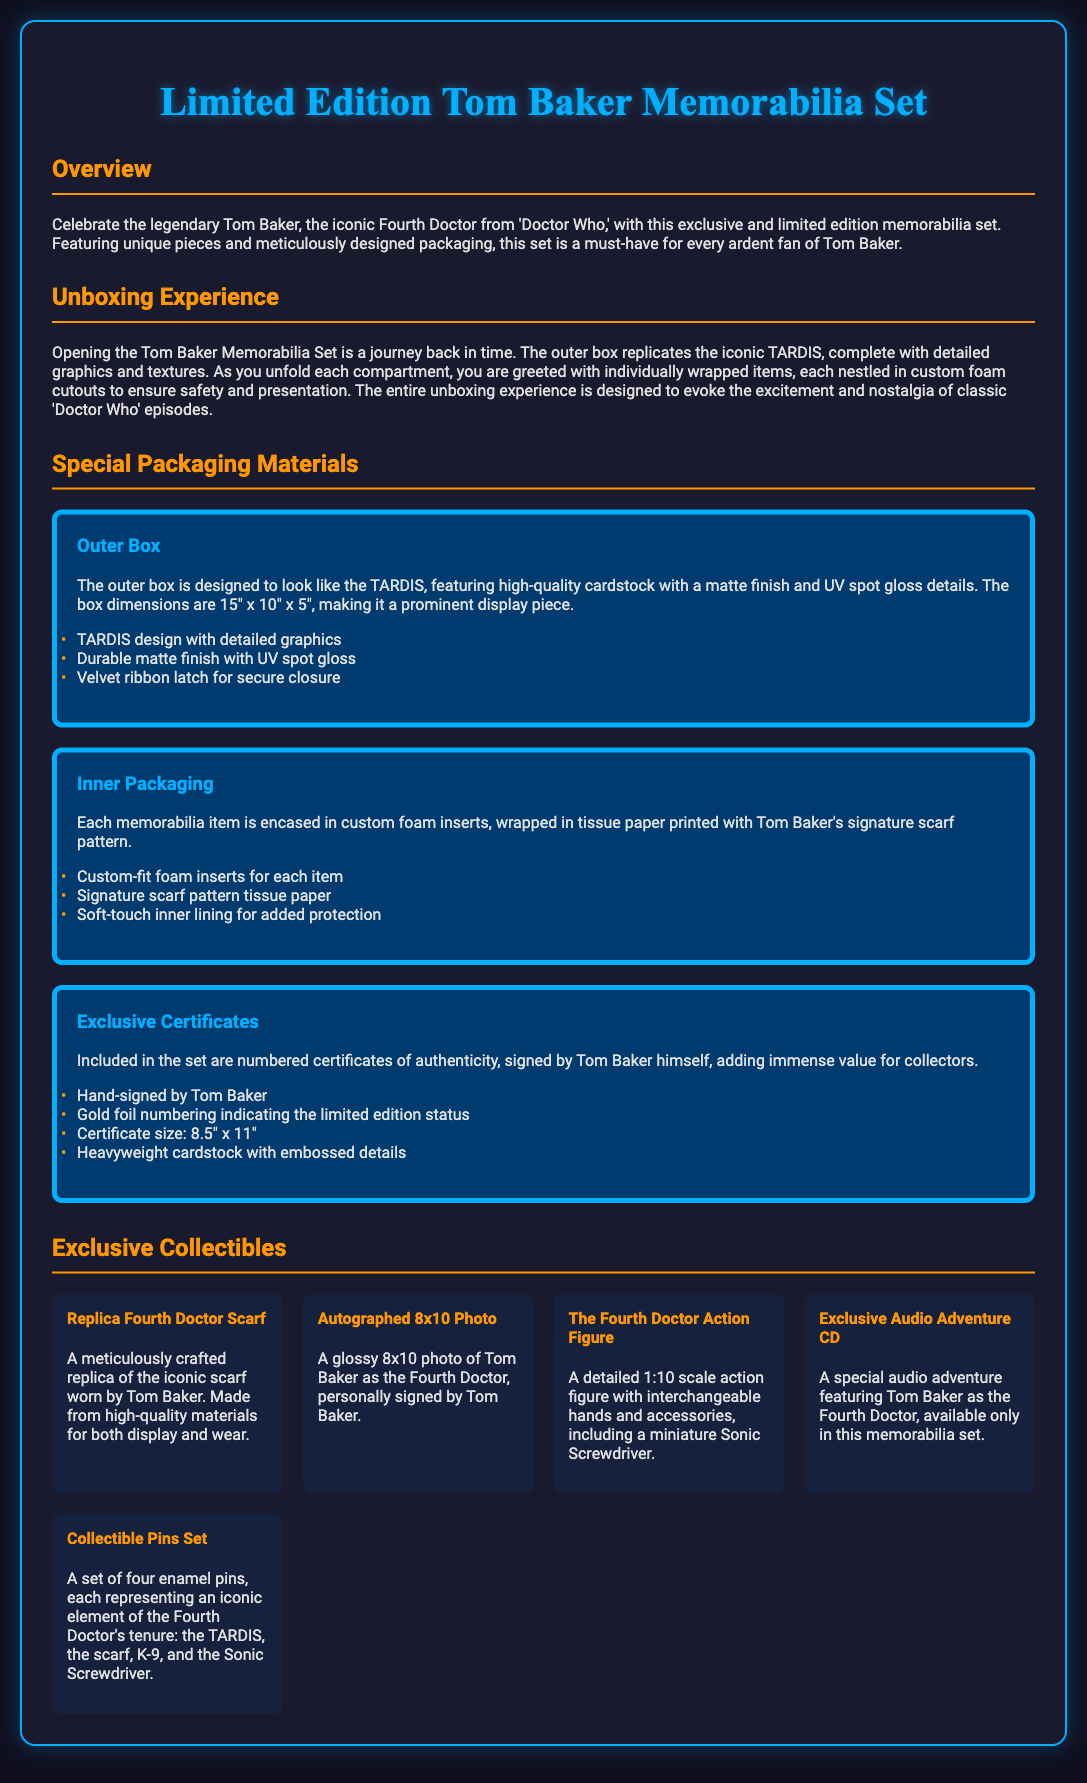What is the main theme of the memorabilia set? The main theme of the set is to celebrate Tom Baker, the iconic Fourth Doctor from 'Doctor Who.'
Answer: Celebrate Tom Baker What are the dimensions of the outer box? The outer box dimensions are specified in the document as 15" x 10" x 5."
Answer: 15" x 10" x 5" What unique packaging material is used in the inner packaging? The inner packaging includes tissue paper printed with Tom Baker's signature scarf pattern.
Answer: Signature scarf pattern tissue paper How many commemorative items are listed in the exclusive collectibles section? The document lists five unique collectible items included in the set.
Answer: Five What feature ensures the outer box closure? A velvet ribbon latch is mentioned as the feature for secure closure of the outer box.
Answer: Velvet ribbon latch Who signs the certificates of authenticity included in the set? The certificates of authenticity are hand-signed by Tom Baker himself.
Answer: Tom Baker What is a notable aspect of the unboxing experience? The unboxing experience is designed to evoke excitement and nostalgia of classic 'Doctor Who' episodes.
Answer: Excitement and nostalgia What type of item is the audio adventure in the collectibles? The audio adventure included is a CD featuring Tom Baker as the Fourth Doctor.
Answer: CD 